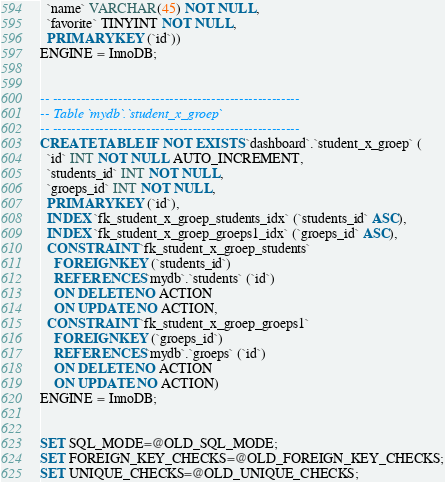<code> <loc_0><loc_0><loc_500><loc_500><_SQL_>  `name` VARCHAR(45) NOT NULL,
  `favorite` TINYINT NOT NULL,
  PRIMARY KEY (`id`))
ENGINE = InnoDB;


-- -----------------------------------------------------
-- Table `mydb`.`student_x_groep`
-- -----------------------------------------------------
CREATE TABLE IF NOT EXISTS `dashboard`.`student_x_groep` (
  `id` INT NOT NULL AUTO_INCREMENT,
  `students_id` INT NOT NULL,
  `groeps_id` INT NOT NULL,
  PRIMARY KEY (`id`),
  INDEX `fk_student_x_groep_students_idx` (`students_id` ASC),
  INDEX `fk_student_x_groep_groeps1_idx` (`groeps_id` ASC),
  CONSTRAINT `fk_student_x_groep_students`
    FOREIGN KEY (`students_id`)
    REFERENCES `mydb`.`students` (`id`)
    ON DELETE NO ACTION
    ON UPDATE NO ACTION,
  CONSTRAINT `fk_student_x_groep_groeps1`
    FOREIGN KEY (`groeps_id`)
    REFERENCES `mydb`.`groeps` (`id`)
    ON DELETE NO ACTION
    ON UPDATE NO ACTION)
ENGINE = InnoDB;


SET SQL_MODE=@OLD_SQL_MODE;
SET FOREIGN_KEY_CHECKS=@OLD_FOREIGN_KEY_CHECKS;
SET UNIQUE_CHECKS=@OLD_UNIQUE_CHECKS;
</code> 